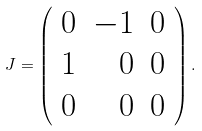<formula> <loc_0><loc_0><loc_500><loc_500>J = \left ( \begin{array} { r r r } 0 & - 1 & 0 \\ 1 & 0 & 0 \\ 0 & 0 & 0 \end{array} \right ) .</formula> 